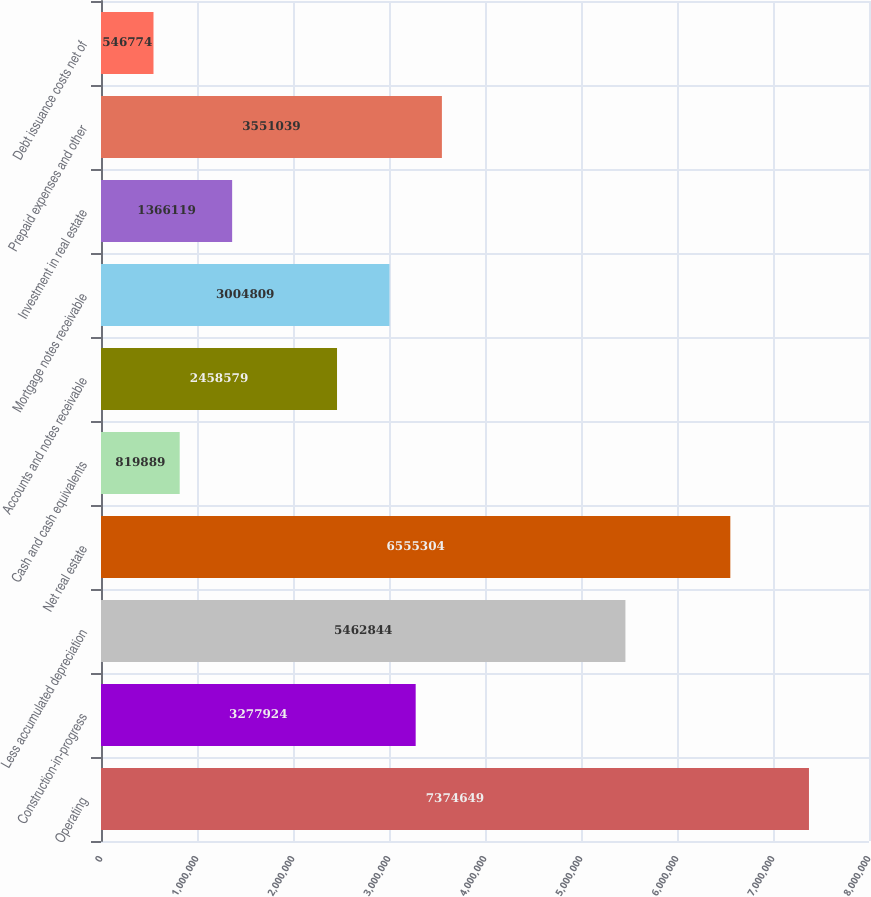<chart> <loc_0><loc_0><loc_500><loc_500><bar_chart><fcel>Operating<fcel>Construction-in-progress<fcel>Less accumulated depreciation<fcel>Net real estate<fcel>Cash and cash equivalents<fcel>Accounts and notes receivable<fcel>Mortgage notes receivable<fcel>Investment in real estate<fcel>Prepaid expenses and other<fcel>Debt issuance costs net of<nl><fcel>7.37465e+06<fcel>3.27792e+06<fcel>5.46284e+06<fcel>6.5553e+06<fcel>819889<fcel>2.45858e+06<fcel>3.00481e+06<fcel>1.36612e+06<fcel>3.55104e+06<fcel>546774<nl></chart> 